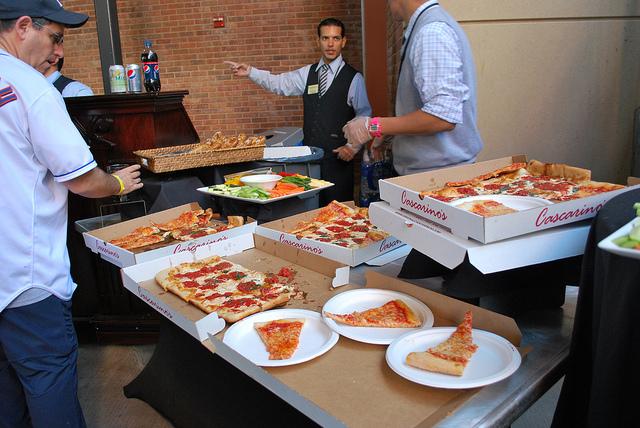Where are the pizzas?
Give a very brief answer. In boxes. What food is being served?
Short answer required. Pizza. Are the men having a party?
Be succinct. Yes. 